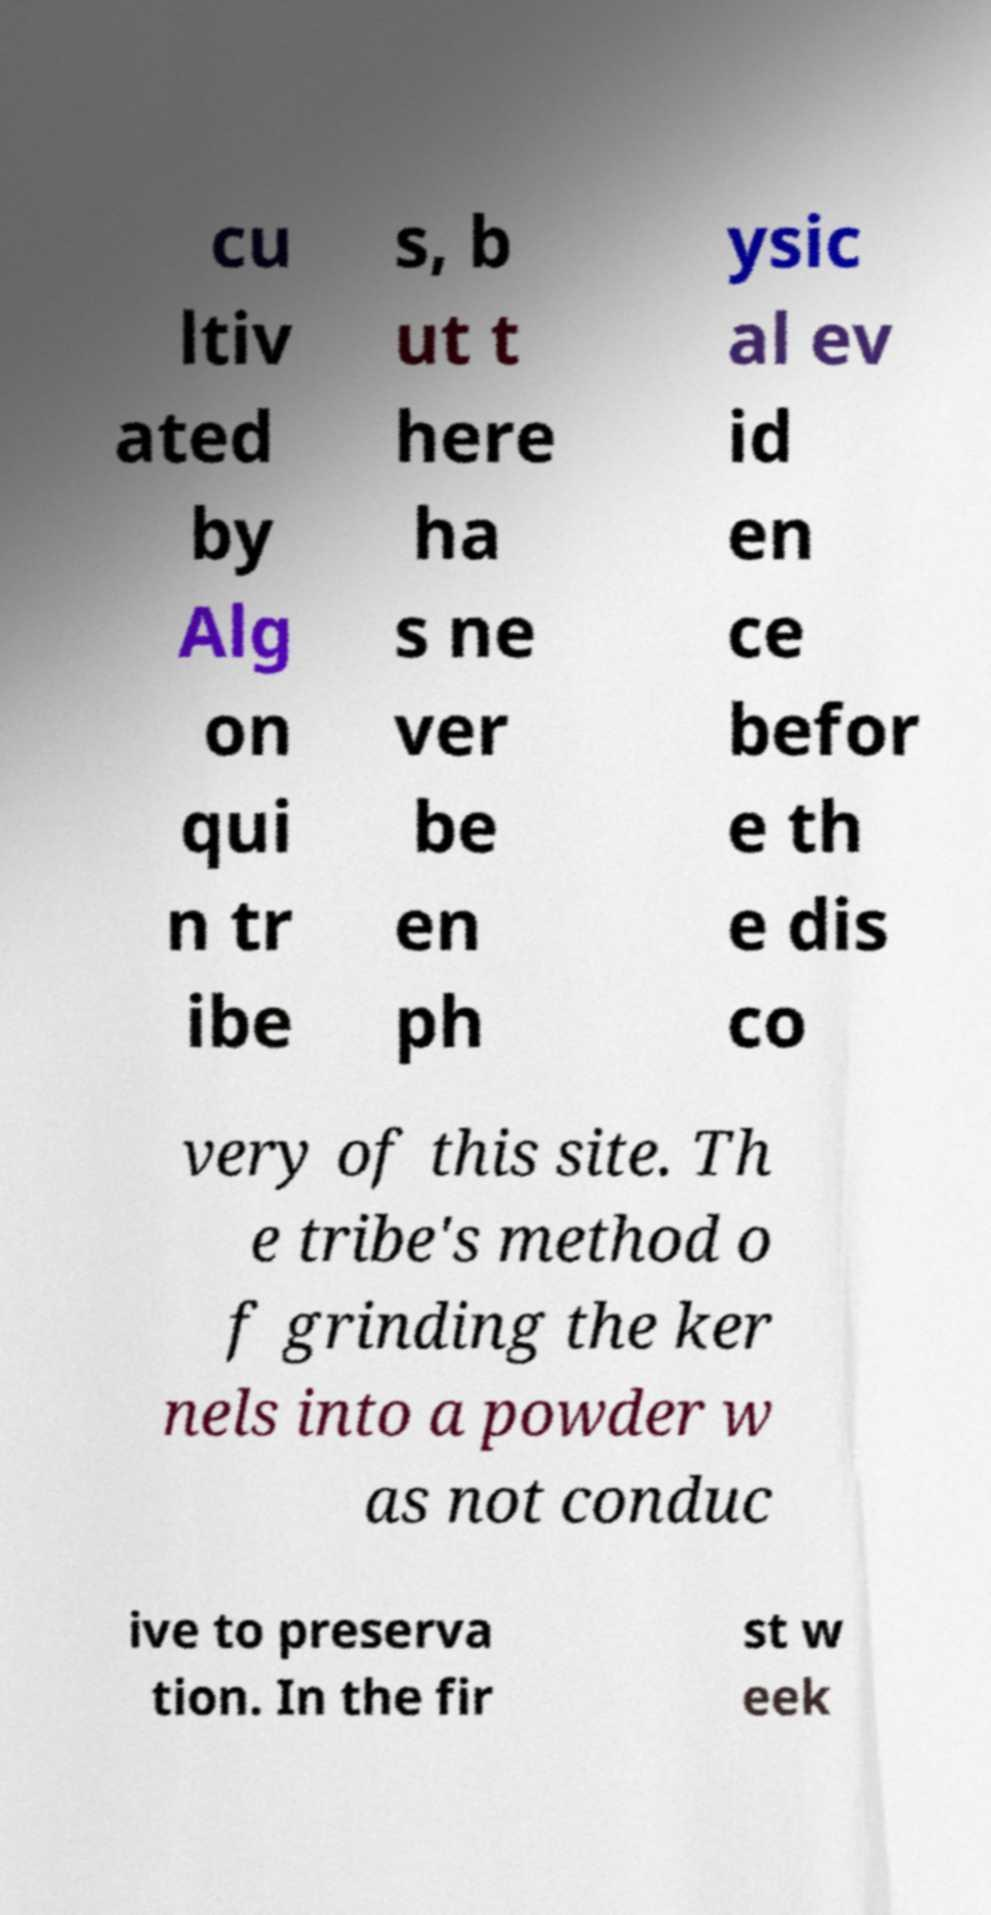Could you extract and type out the text from this image? cu ltiv ated by Alg on qui n tr ibe s, b ut t here ha s ne ver be en ph ysic al ev id en ce befor e th e dis co very of this site. Th e tribe's method o f grinding the ker nels into a powder w as not conduc ive to preserva tion. In the fir st w eek 